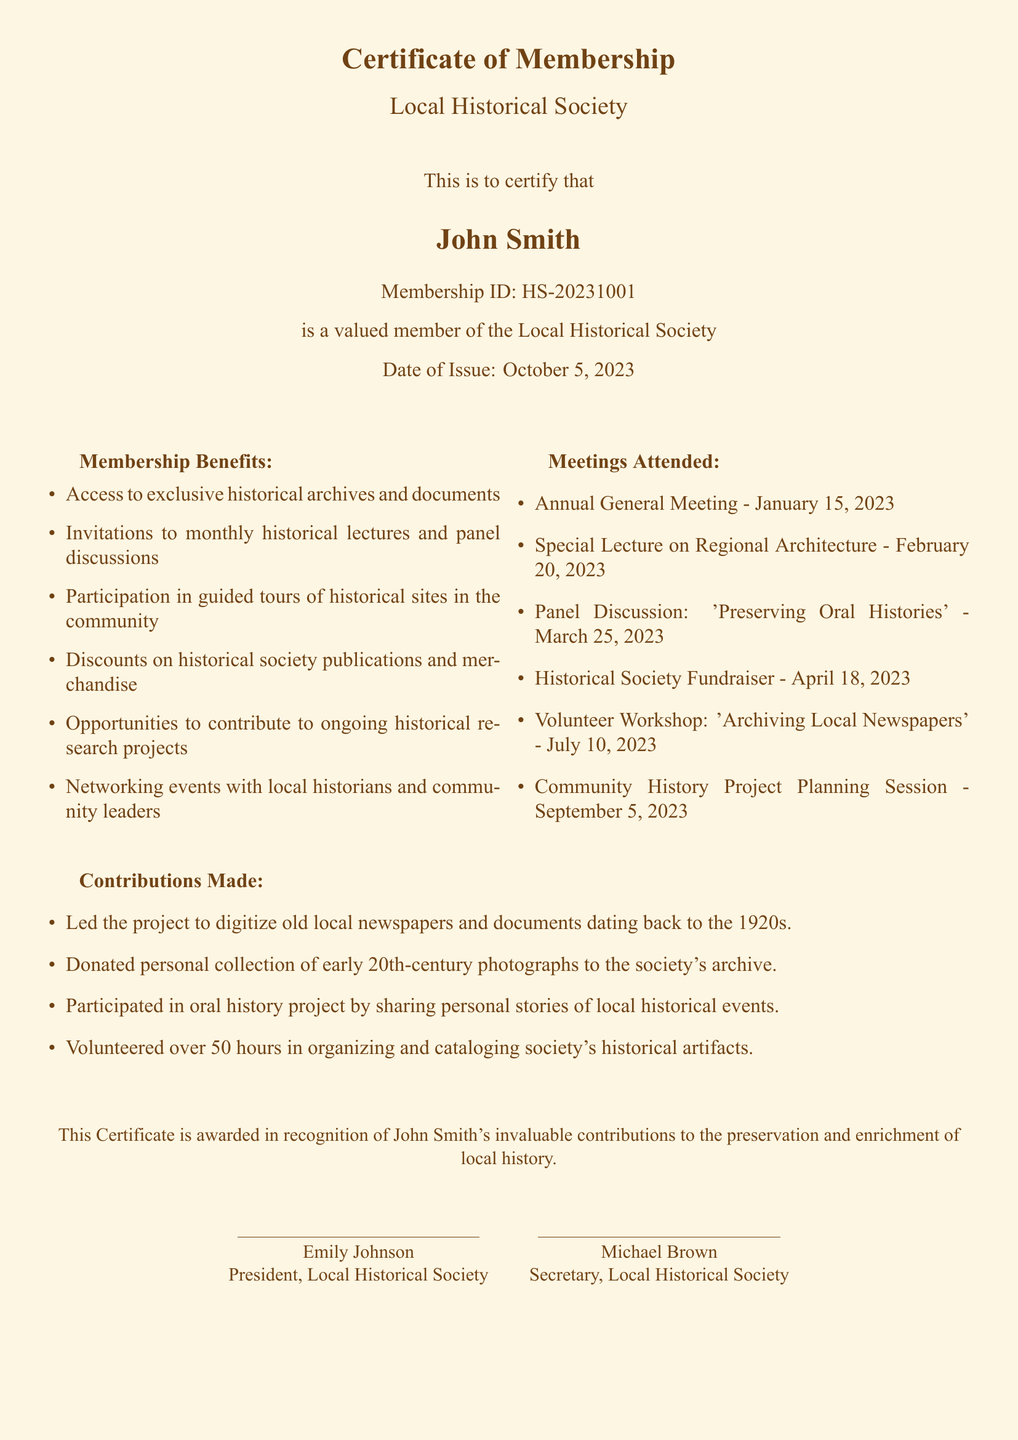What is the name of the member? The member's name is stated prominently in the document.
Answer: John Smith What is the Membership ID? The Membership ID is a unique identifier provided in the document.
Answer: HS-20231001 When was the certificate issued? The date of issue is explicitly mentioned in the document.
Answer: October 5, 2023 What was one of the meetings attended in February 2023? The document lists specific meetings attended, including dates and titles.
Answer: Special Lecture on Regional Architecture How many hours were volunteered in organizing artifacts? The document states the number of hours volunteered in contributions.
Answer: Over 50 hours What is one benefit of membership? The document outlines several benefits of being a member.
Answer: Access to exclusive historical archives and documents What contribution did John Smith make to the digitization project? The document details a specific contribution related to digitization.
Answer: Led the project to digitize old local newspapers and documents Who is the President of the Local Historical Society? The document provides the names and titles of the officials.
Answer: Emily Johnson 